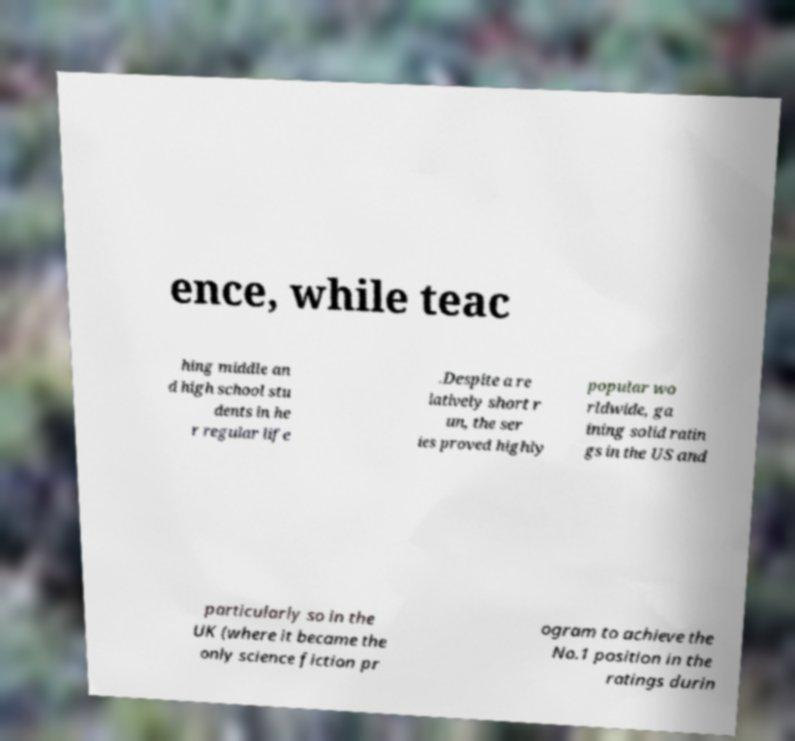Can you read and provide the text displayed in the image?This photo seems to have some interesting text. Can you extract and type it out for me? ence, while teac hing middle an d high school stu dents in he r regular life .Despite a re latively short r un, the ser ies proved highly popular wo rldwide, ga ining solid ratin gs in the US and particularly so in the UK (where it became the only science fiction pr ogram to achieve the No.1 position in the ratings durin 